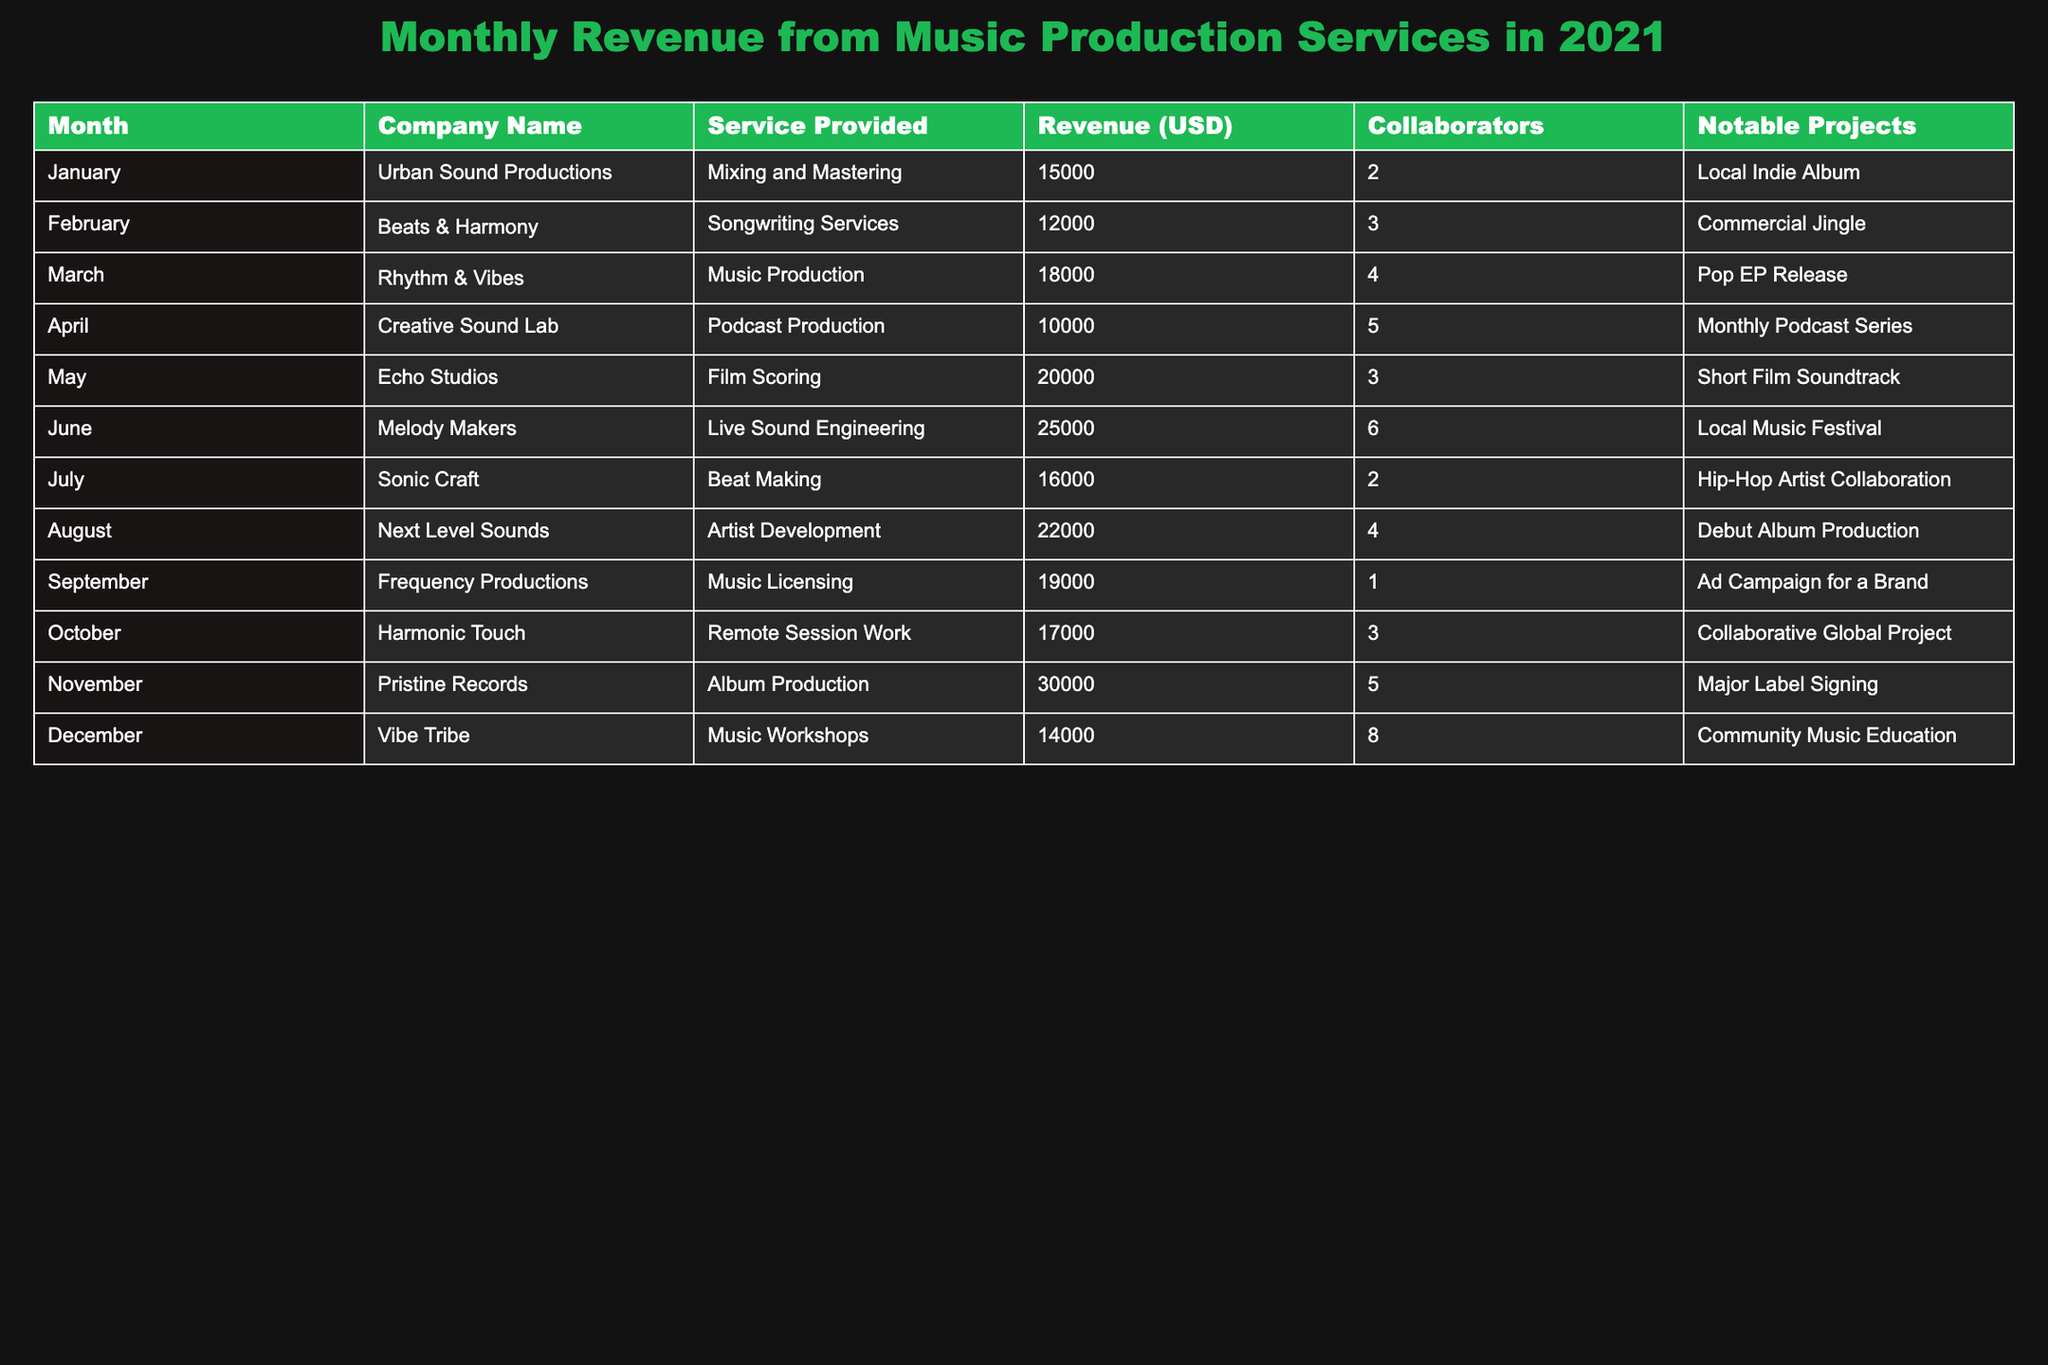What was the highest revenue recorded in December? The revenue in December is $14,000, which is noted in the table under the month of December for Vibe Tribe.
Answer: 14000 Which company provided mixing and mastering services? Urban Sound Productions is the company listed under Mixing and Mastering services for January, with revenue of $15,000.
Answer: Urban Sound Productions What was the total revenue for the months of May and June? The revenue for May is $20,000 and for June is $25,000, so their total is $20,000 + $25,000 = $45,000.
Answer: 45000 How many collaborators were involved in the album production by Pristine Records? The table states that Pristine Records had 5 collaborators for the album production in November.
Answer: 5 Which service had the lowest revenue, and what was that amount? The service with the lowest revenue is Podcast Production by Creative Sound Lab, with a revenue of $10,000 in April.
Answer: 10000 Is there a service provided by only one collaborator? Yes, Frequency Productions provided music licensing services in September with 1 collaborator.
Answer: Yes What are the average revenues for the months of January to June? The total revenues for these months are $15,000 + $12,000 + $18,000 + $10,000 + $20,000 + $25,000 = $100,000, and there are 6 months. The average would be $100,000 / 6 ≈ $16,667.
Answer: 16667 Which month had the highest revenue from artist development? August had the highest revenue of $22,000 for artist development provided by Next Level Sounds.
Answer: August Are there more months with a revenue greater than $20,000 or less than $20,000? The counts show that there are 5 months with more than $20,000 (May, June, August, September, November) and 7 with less than $20,000. Holding Count gives the answer more toward the lower revenue side.
Answer: Less than $20,000 What was the difference in revenue between the highest month and the lowest month? The highest revenue was $30,000 in November, while the lowest was $10,000 in April. The difference is $30,000 - $10,000 = $20,000.
Answer: 20000 